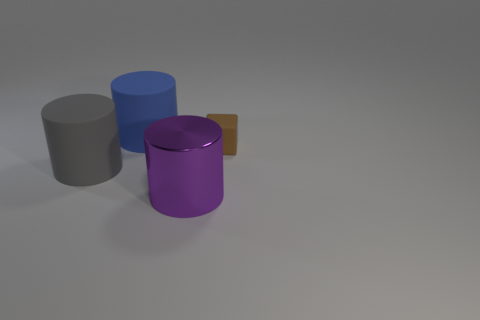Subtract all rubber cylinders. How many cylinders are left? 1 Subtract 2 cylinders. How many cylinders are left? 1 Subtract all gray cylinders. How many cylinders are left? 2 Subtract all cylinders. How many objects are left? 1 Subtract 0 gray spheres. How many objects are left? 4 Subtract all gray blocks. Subtract all brown cylinders. How many blocks are left? 1 Subtract all red balls. How many blue blocks are left? 0 Subtract all red metallic blocks. Subtract all big blue matte cylinders. How many objects are left? 3 Add 1 large gray things. How many large gray things are left? 2 Add 2 gray things. How many gray things exist? 3 